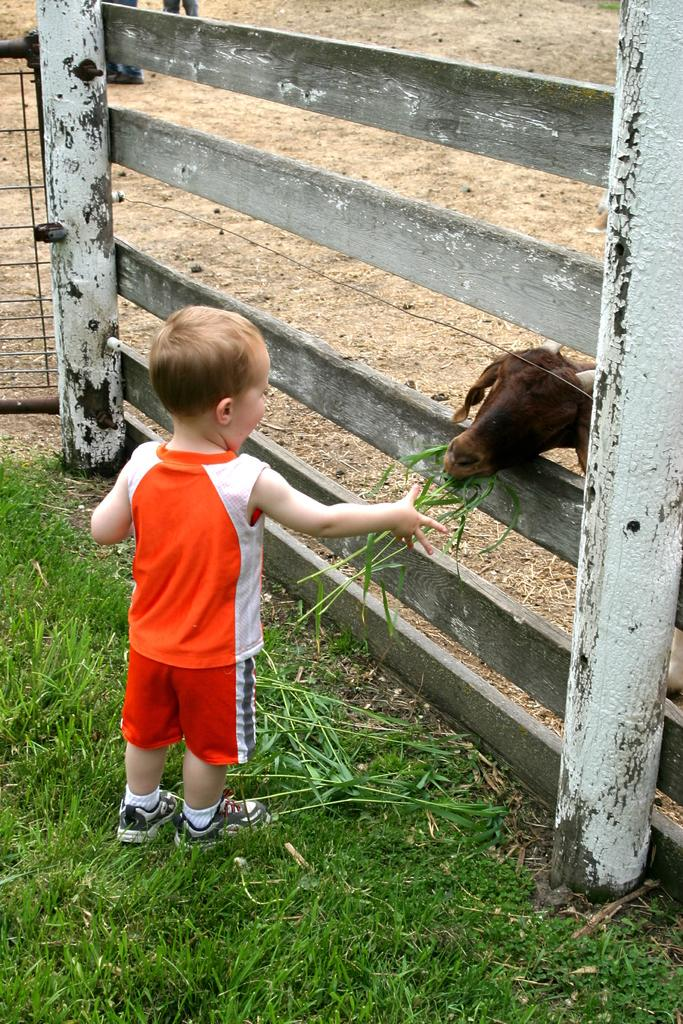Who is the main subject in the image? There is a small boy in the image. What is the boy standing on? The boy is standing on a grass surface. Where is the boy located in relation to the railing? The boy is near a railing. What is the boy doing in the image? The boy is feeding a goat. Where is the goat located in the image? The goat is behind the railing. What is the goat being fed with? The goat is being fed with grass. What rule is the boy following while feeding the goat in the image? There is no mention of any rules in the image, so it is not possible to determine if the boy is following any rules while feeding the goat. 